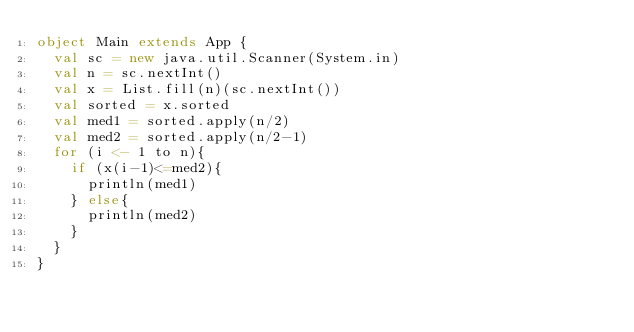Convert code to text. <code><loc_0><loc_0><loc_500><loc_500><_Scala_>object Main extends App {
  val sc = new java.util.Scanner(System.in)
  val n = sc.nextInt()
  val x = List.fill(n)(sc.nextInt())
  val sorted = x.sorted
  val med1 = sorted.apply(n/2)
  val med2 = sorted.apply(n/2-1)
  for (i <- 1 to n){
    if (x(i-1)<=med2){
      println(med1)
    } else{
      println(med2)
    }
  }
}</code> 